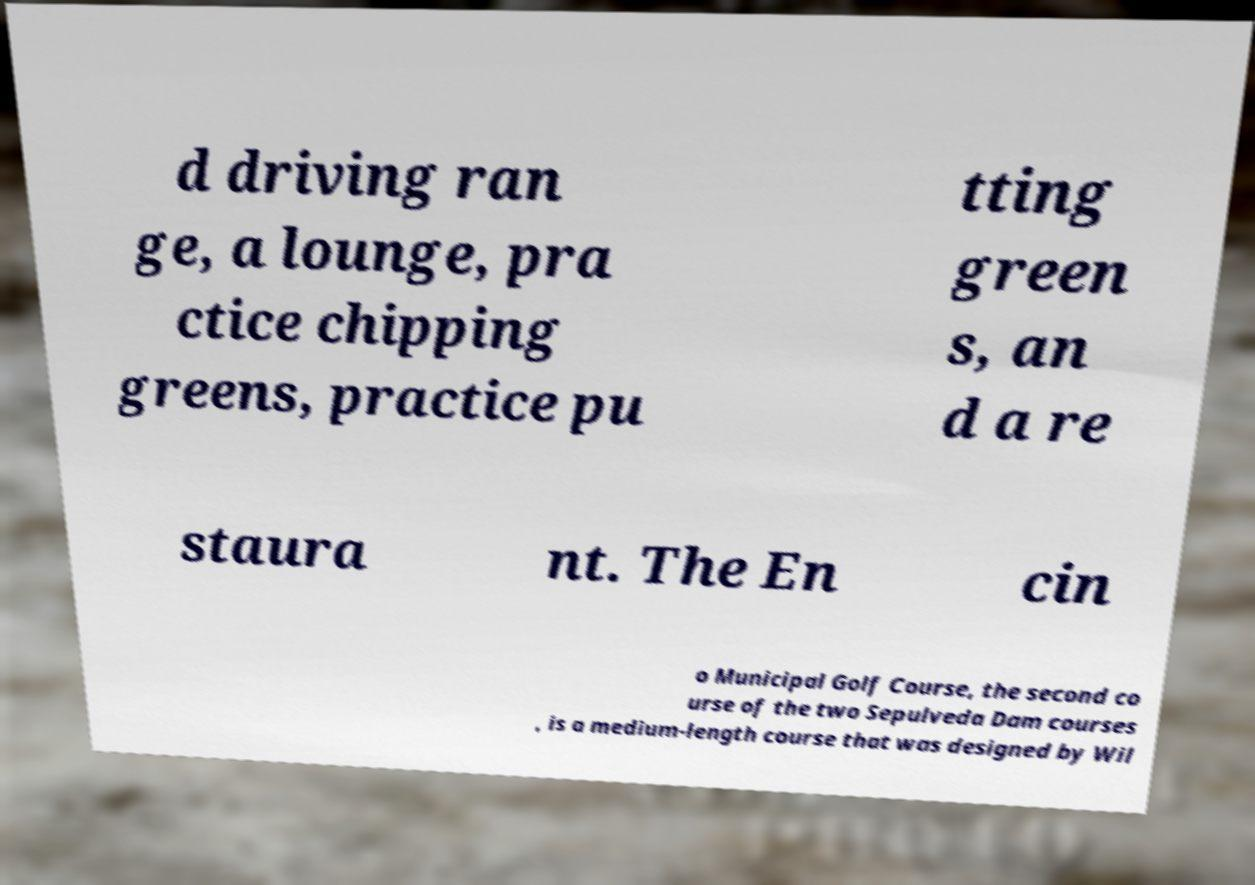Can you accurately transcribe the text from the provided image for me? d driving ran ge, a lounge, pra ctice chipping greens, practice pu tting green s, an d a re staura nt. The En cin o Municipal Golf Course, the second co urse of the two Sepulveda Dam courses , is a medium-length course that was designed by Wil 